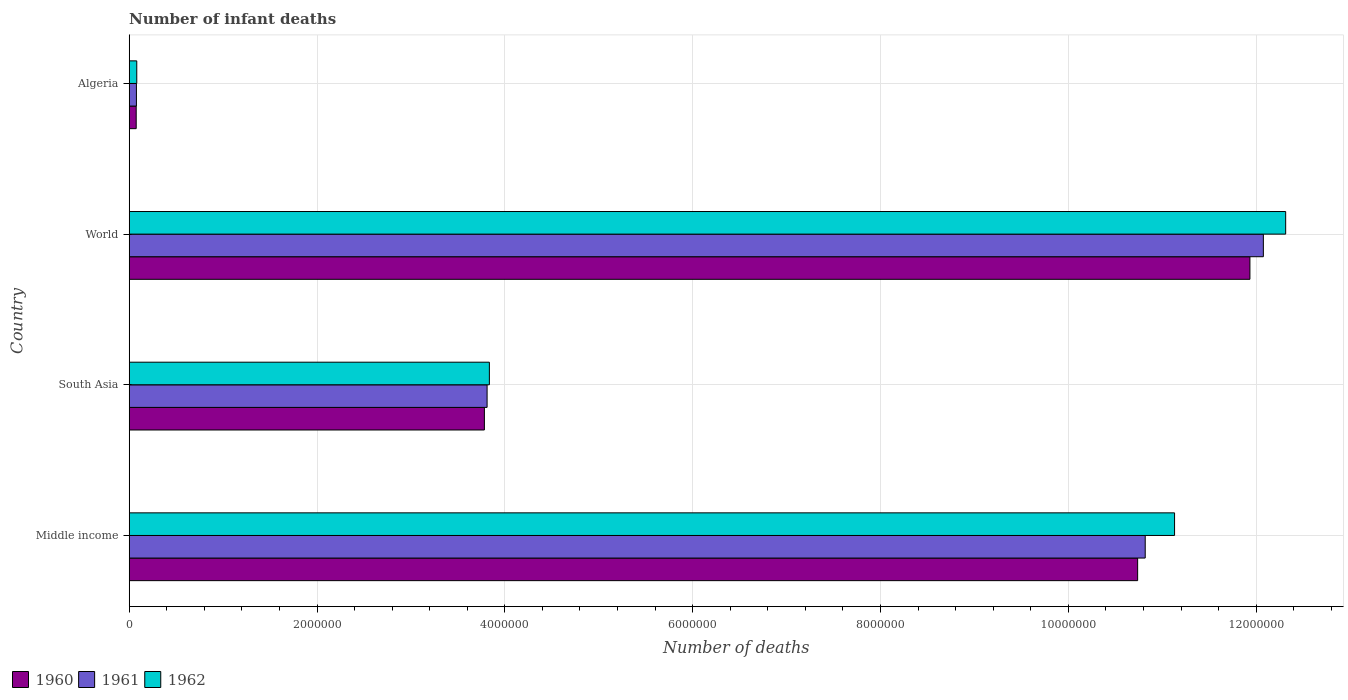How many groups of bars are there?
Provide a short and direct response. 4. Are the number of bars per tick equal to the number of legend labels?
Provide a short and direct response. Yes. How many bars are there on the 3rd tick from the top?
Make the answer very short. 3. How many bars are there on the 1st tick from the bottom?
Your response must be concise. 3. What is the label of the 4th group of bars from the top?
Make the answer very short. Middle income. What is the number of infant deaths in 1960 in Algeria?
Offer a very short reply. 7.45e+04. Across all countries, what is the maximum number of infant deaths in 1961?
Provide a succinct answer. 1.21e+07. Across all countries, what is the minimum number of infant deaths in 1960?
Your answer should be compact. 7.45e+04. In which country was the number of infant deaths in 1962 maximum?
Provide a short and direct response. World. In which country was the number of infant deaths in 1960 minimum?
Ensure brevity in your answer.  Algeria. What is the total number of infant deaths in 1960 in the graph?
Offer a very short reply. 2.65e+07. What is the difference between the number of infant deaths in 1961 in Middle income and that in World?
Make the answer very short. -1.26e+06. What is the difference between the number of infant deaths in 1961 in South Asia and the number of infant deaths in 1962 in World?
Your answer should be very brief. -8.50e+06. What is the average number of infant deaths in 1962 per country?
Make the answer very short. 6.84e+06. What is the difference between the number of infant deaths in 1960 and number of infant deaths in 1962 in Algeria?
Offer a terse response. -5926. In how many countries, is the number of infant deaths in 1960 greater than 6400000 ?
Your response must be concise. 2. What is the ratio of the number of infant deaths in 1960 in Algeria to that in South Asia?
Your response must be concise. 0.02. What is the difference between the highest and the second highest number of infant deaths in 1960?
Your response must be concise. 1.20e+06. What is the difference between the highest and the lowest number of infant deaths in 1961?
Offer a terse response. 1.20e+07. What does the 3rd bar from the top in Middle income represents?
Ensure brevity in your answer.  1960. How many bars are there?
Give a very brief answer. 12. How many countries are there in the graph?
Offer a terse response. 4. Does the graph contain any zero values?
Provide a succinct answer. No. Where does the legend appear in the graph?
Offer a terse response. Bottom left. What is the title of the graph?
Provide a succinct answer. Number of infant deaths. Does "1991" appear as one of the legend labels in the graph?
Give a very brief answer. No. What is the label or title of the X-axis?
Make the answer very short. Number of deaths. What is the label or title of the Y-axis?
Provide a succinct answer. Country. What is the Number of deaths of 1960 in Middle income?
Your answer should be very brief. 1.07e+07. What is the Number of deaths of 1961 in Middle income?
Your response must be concise. 1.08e+07. What is the Number of deaths of 1962 in Middle income?
Make the answer very short. 1.11e+07. What is the Number of deaths of 1960 in South Asia?
Offer a terse response. 3.78e+06. What is the Number of deaths of 1961 in South Asia?
Make the answer very short. 3.81e+06. What is the Number of deaths of 1962 in South Asia?
Offer a terse response. 3.84e+06. What is the Number of deaths in 1960 in World?
Your answer should be very brief. 1.19e+07. What is the Number of deaths of 1961 in World?
Provide a succinct answer. 1.21e+07. What is the Number of deaths in 1962 in World?
Your answer should be very brief. 1.23e+07. What is the Number of deaths in 1960 in Algeria?
Make the answer very short. 7.45e+04. What is the Number of deaths of 1961 in Algeria?
Your response must be concise. 7.68e+04. What is the Number of deaths of 1962 in Algeria?
Provide a short and direct response. 8.05e+04. Across all countries, what is the maximum Number of deaths of 1960?
Keep it short and to the point. 1.19e+07. Across all countries, what is the maximum Number of deaths of 1961?
Make the answer very short. 1.21e+07. Across all countries, what is the maximum Number of deaths of 1962?
Your response must be concise. 1.23e+07. Across all countries, what is the minimum Number of deaths of 1960?
Provide a short and direct response. 7.45e+04. Across all countries, what is the minimum Number of deaths of 1961?
Offer a terse response. 7.68e+04. Across all countries, what is the minimum Number of deaths of 1962?
Provide a short and direct response. 8.05e+04. What is the total Number of deaths of 1960 in the graph?
Your response must be concise. 2.65e+07. What is the total Number of deaths in 1961 in the graph?
Ensure brevity in your answer.  2.68e+07. What is the total Number of deaths of 1962 in the graph?
Offer a very short reply. 2.74e+07. What is the difference between the Number of deaths in 1960 in Middle income and that in South Asia?
Give a very brief answer. 6.96e+06. What is the difference between the Number of deaths of 1961 in Middle income and that in South Asia?
Your answer should be very brief. 7.01e+06. What is the difference between the Number of deaths in 1962 in Middle income and that in South Asia?
Your response must be concise. 7.30e+06. What is the difference between the Number of deaths in 1960 in Middle income and that in World?
Keep it short and to the point. -1.20e+06. What is the difference between the Number of deaths of 1961 in Middle income and that in World?
Keep it short and to the point. -1.26e+06. What is the difference between the Number of deaths of 1962 in Middle income and that in World?
Your answer should be very brief. -1.18e+06. What is the difference between the Number of deaths of 1960 in Middle income and that in Algeria?
Give a very brief answer. 1.07e+07. What is the difference between the Number of deaths of 1961 in Middle income and that in Algeria?
Your answer should be compact. 1.07e+07. What is the difference between the Number of deaths of 1962 in Middle income and that in Algeria?
Your answer should be compact. 1.11e+07. What is the difference between the Number of deaths in 1960 in South Asia and that in World?
Ensure brevity in your answer.  -8.15e+06. What is the difference between the Number of deaths of 1961 in South Asia and that in World?
Ensure brevity in your answer.  -8.27e+06. What is the difference between the Number of deaths of 1962 in South Asia and that in World?
Provide a succinct answer. -8.48e+06. What is the difference between the Number of deaths of 1960 in South Asia and that in Algeria?
Make the answer very short. 3.71e+06. What is the difference between the Number of deaths in 1961 in South Asia and that in Algeria?
Ensure brevity in your answer.  3.73e+06. What is the difference between the Number of deaths of 1962 in South Asia and that in Algeria?
Your response must be concise. 3.75e+06. What is the difference between the Number of deaths in 1960 in World and that in Algeria?
Ensure brevity in your answer.  1.19e+07. What is the difference between the Number of deaths of 1961 in World and that in Algeria?
Provide a short and direct response. 1.20e+07. What is the difference between the Number of deaths of 1962 in World and that in Algeria?
Keep it short and to the point. 1.22e+07. What is the difference between the Number of deaths in 1960 in Middle income and the Number of deaths in 1961 in South Asia?
Your response must be concise. 6.93e+06. What is the difference between the Number of deaths of 1960 in Middle income and the Number of deaths of 1962 in South Asia?
Your response must be concise. 6.90e+06. What is the difference between the Number of deaths in 1961 in Middle income and the Number of deaths in 1962 in South Asia?
Offer a very short reply. 6.98e+06. What is the difference between the Number of deaths of 1960 in Middle income and the Number of deaths of 1961 in World?
Provide a succinct answer. -1.34e+06. What is the difference between the Number of deaths of 1960 in Middle income and the Number of deaths of 1962 in World?
Provide a short and direct response. -1.58e+06. What is the difference between the Number of deaths of 1961 in Middle income and the Number of deaths of 1962 in World?
Make the answer very short. -1.50e+06. What is the difference between the Number of deaths of 1960 in Middle income and the Number of deaths of 1961 in Algeria?
Make the answer very short. 1.07e+07. What is the difference between the Number of deaths of 1960 in Middle income and the Number of deaths of 1962 in Algeria?
Make the answer very short. 1.07e+07. What is the difference between the Number of deaths of 1961 in Middle income and the Number of deaths of 1962 in Algeria?
Give a very brief answer. 1.07e+07. What is the difference between the Number of deaths in 1960 in South Asia and the Number of deaths in 1961 in World?
Offer a terse response. -8.29e+06. What is the difference between the Number of deaths of 1960 in South Asia and the Number of deaths of 1962 in World?
Ensure brevity in your answer.  -8.53e+06. What is the difference between the Number of deaths in 1961 in South Asia and the Number of deaths in 1962 in World?
Give a very brief answer. -8.50e+06. What is the difference between the Number of deaths of 1960 in South Asia and the Number of deaths of 1961 in Algeria?
Your answer should be compact. 3.71e+06. What is the difference between the Number of deaths in 1960 in South Asia and the Number of deaths in 1962 in Algeria?
Your answer should be compact. 3.70e+06. What is the difference between the Number of deaths in 1961 in South Asia and the Number of deaths in 1962 in Algeria?
Make the answer very short. 3.73e+06. What is the difference between the Number of deaths in 1960 in World and the Number of deaths in 1961 in Algeria?
Make the answer very short. 1.19e+07. What is the difference between the Number of deaths in 1960 in World and the Number of deaths in 1962 in Algeria?
Give a very brief answer. 1.19e+07. What is the difference between the Number of deaths in 1961 in World and the Number of deaths in 1962 in Algeria?
Make the answer very short. 1.20e+07. What is the average Number of deaths in 1960 per country?
Your answer should be very brief. 6.63e+06. What is the average Number of deaths of 1961 per country?
Your answer should be compact. 6.70e+06. What is the average Number of deaths in 1962 per country?
Provide a short and direct response. 6.84e+06. What is the difference between the Number of deaths in 1960 and Number of deaths in 1961 in Middle income?
Your answer should be compact. -8.05e+04. What is the difference between the Number of deaths of 1960 and Number of deaths of 1962 in Middle income?
Offer a terse response. -3.93e+05. What is the difference between the Number of deaths of 1961 and Number of deaths of 1962 in Middle income?
Give a very brief answer. -3.13e+05. What is the difference between the Number of deaths of 1960 and Number of deaths of 1961 in South Asia?
Offer a very short reply. -2.87e+04. What is the difference between the Number of deaths of 1960 and Number of deaths of 1962 in South Asia?
Offer a very short reply. -5.30e+04. What is the difference between the Number of deaths in 1961 and Number of deaths in 1962 in South Asia?
Ensure brevity in your answer.  -2.43e+04. What is the difference between the Number of deaths in 1960 and Number of deaths in 1961 in World?
Your answer should be compact. -1.43e+05. What is the difference between the Number of deaths in 1960 and Number of deaths in 1962 in World?
Give a very brief answer. -3.81e+05. What is the difference between the Number of deaths of 1961 and Number of deaths of 1962 in World?
Keep it short and to the point. -2.37e+05. What is the difference between the Number of deaths of 1960 and Number of deaths of 1961 in Algeria?
Offer a very short reply. -2242. What is the difference between the Number of deaths of 1960 and Number of deaths of 1962 in Algeria?
Provide a short and direct response. -5926. What is the difference between the Number of deaths of 1961 and Number of deaths of 1962 in Algeria?
Give a very brief answer. -3684. What is the ratio of the Number of deaths of 1960 in Middle income to that in South Asia?
Ensure brevity in your answer.  2.84. What is the ratio of the Number of deaths of 1961 in Middle income to that in South Asia?
Give a very brief answer. 2.84. What is the ratio of the Number of deaths in 1962 in Middle income to that in South Asia?
Make the answer very short. 2.9. What is the ratio of the Number of deaths of 1960 in Middle income to that in World?
Ensure brevity in your answer.  0.9. What is the ratio of the Number of deaths of 1961 in Middle income to that in World?
Give a very brief answer. 0.9. What is the ratio of the Number of deaths in 1962 in Middle income to that in World?
Ensure brevity in your answer.  0.9. What is the ratio of the Number of deaths of 1960 in Middle income to that in Algeria?
Provide a succinct answer. 144.05. What is the ratio of the Number of deaths of 1961 in Middle income to that in Algeria?
Provide a short and direct response. 140.89. What is the ratio of the Number of deaths of 1962 in Middle income to that in Algeria?
Offer a very short reply. 138.32. What is the ratio of the Number of deaths in 1960 in South Asia to that in World?
Keep it short and to the point. 0.32. What is the ratio of the Number of deaths in 1961 in South Asia to that in World?
Your answer should be very brief. 0.32. What is the ratio of the Number of deaths of 1962 in South Asia to that in World?
Your response must be concise. 0.31. What is the ratio of the Number of deaths of 1960 in South Asia to that in Algeria?
Offer a very short reply. 50.73. What is the ratio of the Number of deaths in 1961 in South Asia to that in Algeria?
Ensure brevity in your answer.  49.63. What is the ratio of the Number of deaths in 1962 in South Asia to that in Algeria?
Provide a short and direct response. 47.66. What is the ratio of the Number of deaths in 1960 in World to that in Algeria?
Ensure brevity in your answer.  160.08. What is the ratio of the Number of deaths of 1961 in World to that in Algeria?
Give a very brief answer. 157.27. What is the ratio of the Number of deaths in 1962 in World to that in Algeria?
Keep it short and to the point. 153.02. What is the difference between the highest and the second highest Number of deaths in 1960?
Give a very brief answer. 1.20e+06. What is the difference between the highest and the second highest Number of deaths of 1961?
Give a very brief answer. 1.26e+06. What is the difference between the highest and the second highest Number of deaths in 1962?
Keep it short and to the point. 1.18e+06. What is the difference between the highest and the lowest Number of deaths of 1960?
Your response must be concise. 1.19e+07. What is the difference between the highest and the lowest Number of deaths in 1961?
Provide a succinct answer. 1.20e+07. What is the difference between the highest and the lowest Number of deaths of 1962?
Provide a succinct answer. 1.22e+07. 